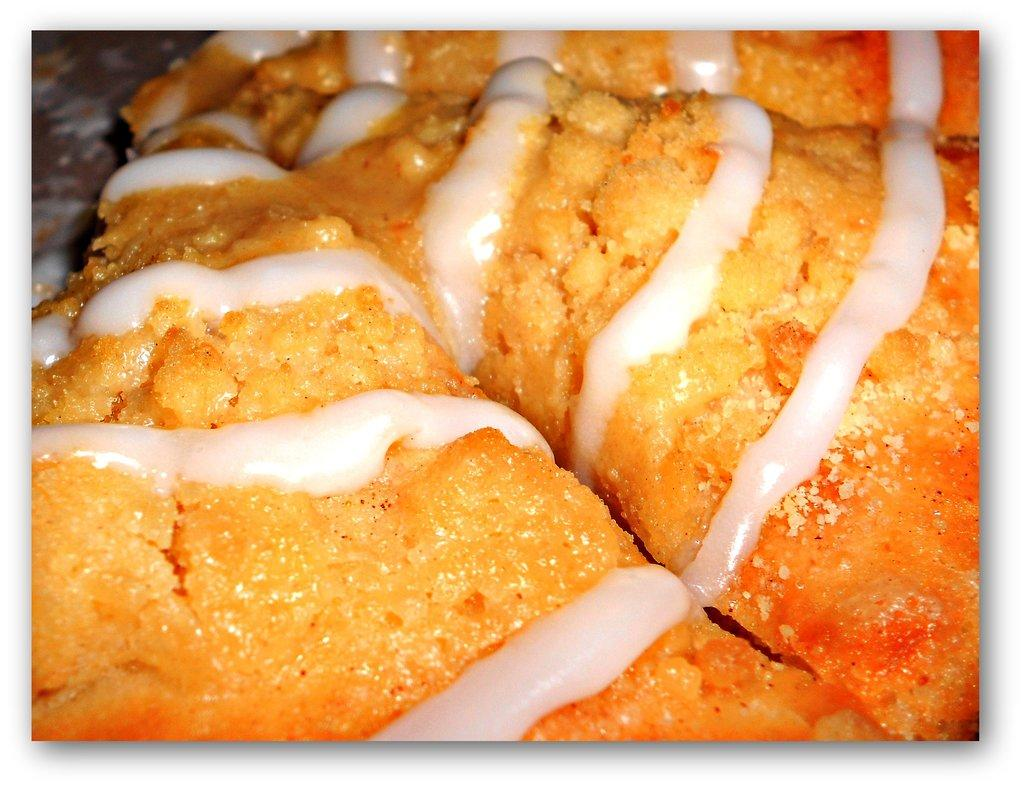What is present on the surface in the image? There is food on a surface in the image. Can you describe the food in more detail? Unfortunately, the facts provided do not give any specific details about the food. What type of surface is the food placed on? The facts provided do not specify the type of surface. How does the food control the process of jumping in the image? There is no mention of jumping or a process being controlled in the image. The image only shows food on a surface. 